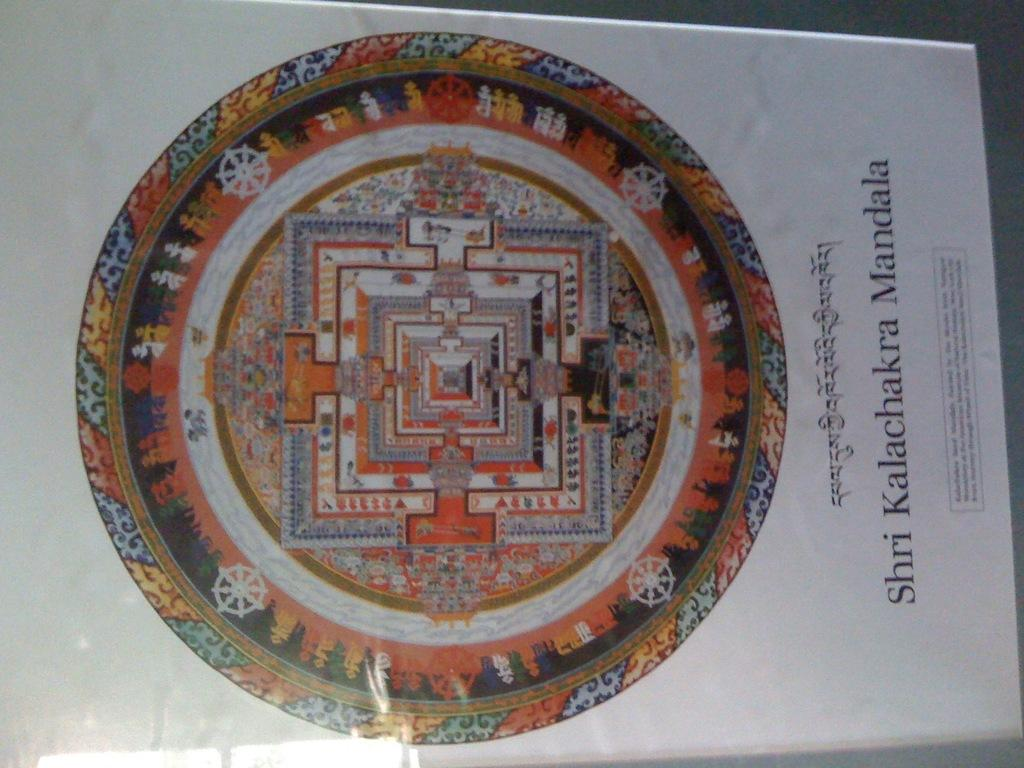<image>
Render a clear and concise summary of the photo. A colourful circle with the words Shri KalachakMandala below 